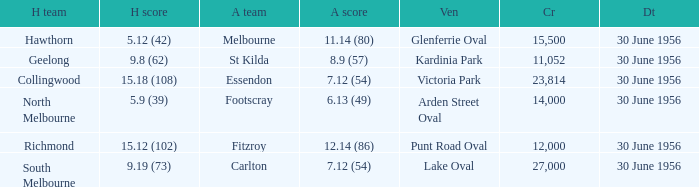What is the home team at Victoria Park with an Away team score of 7.12 (54) and more than 12,000 people? Collingwood. 